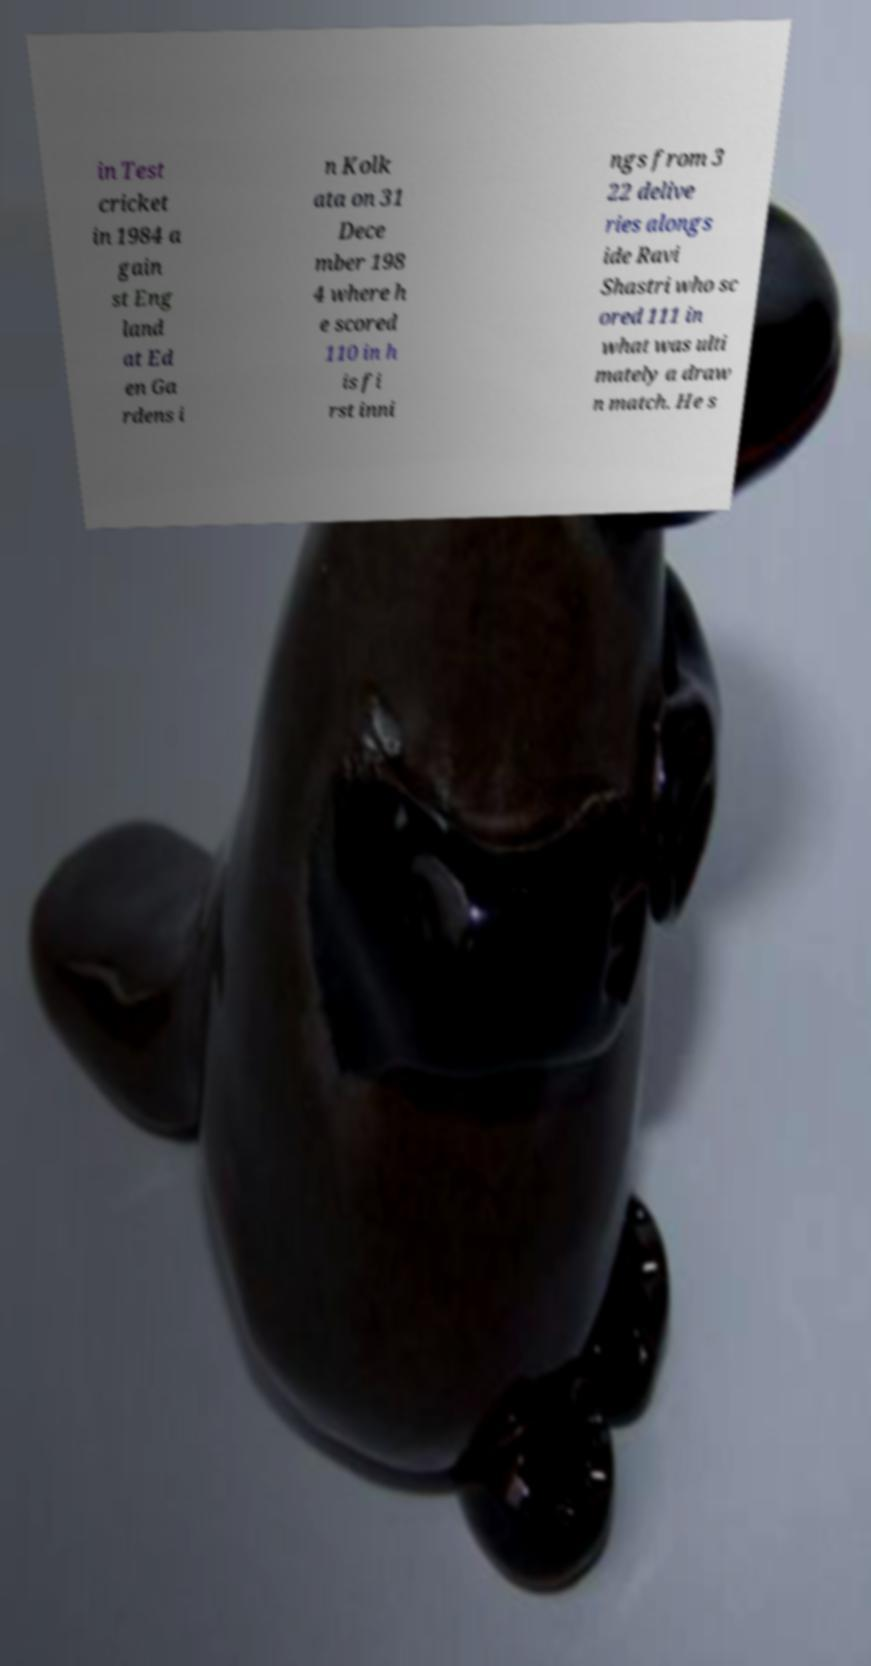For documentation purposes, I need the text within this image transcribed. Could you provide that? in Test cricket in 1984 a gain st Eng land at Ed en Ga rdens i n Kolk ata on 31 Dece mber 198 4 where h e scored 110 in h is fi rst inni ngs from 3 22 delive ries alongs ide Ravi Shastri who sc ored 111 in what was ulti mately a draw n match. He s 